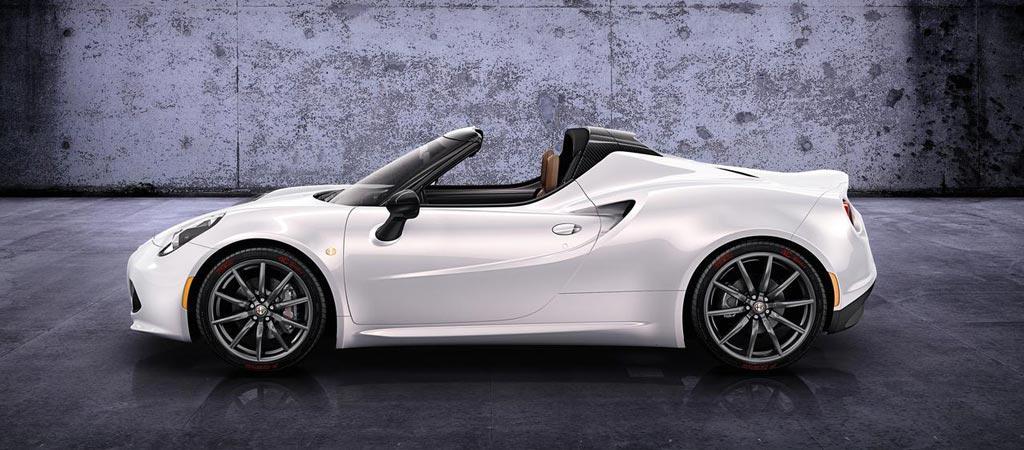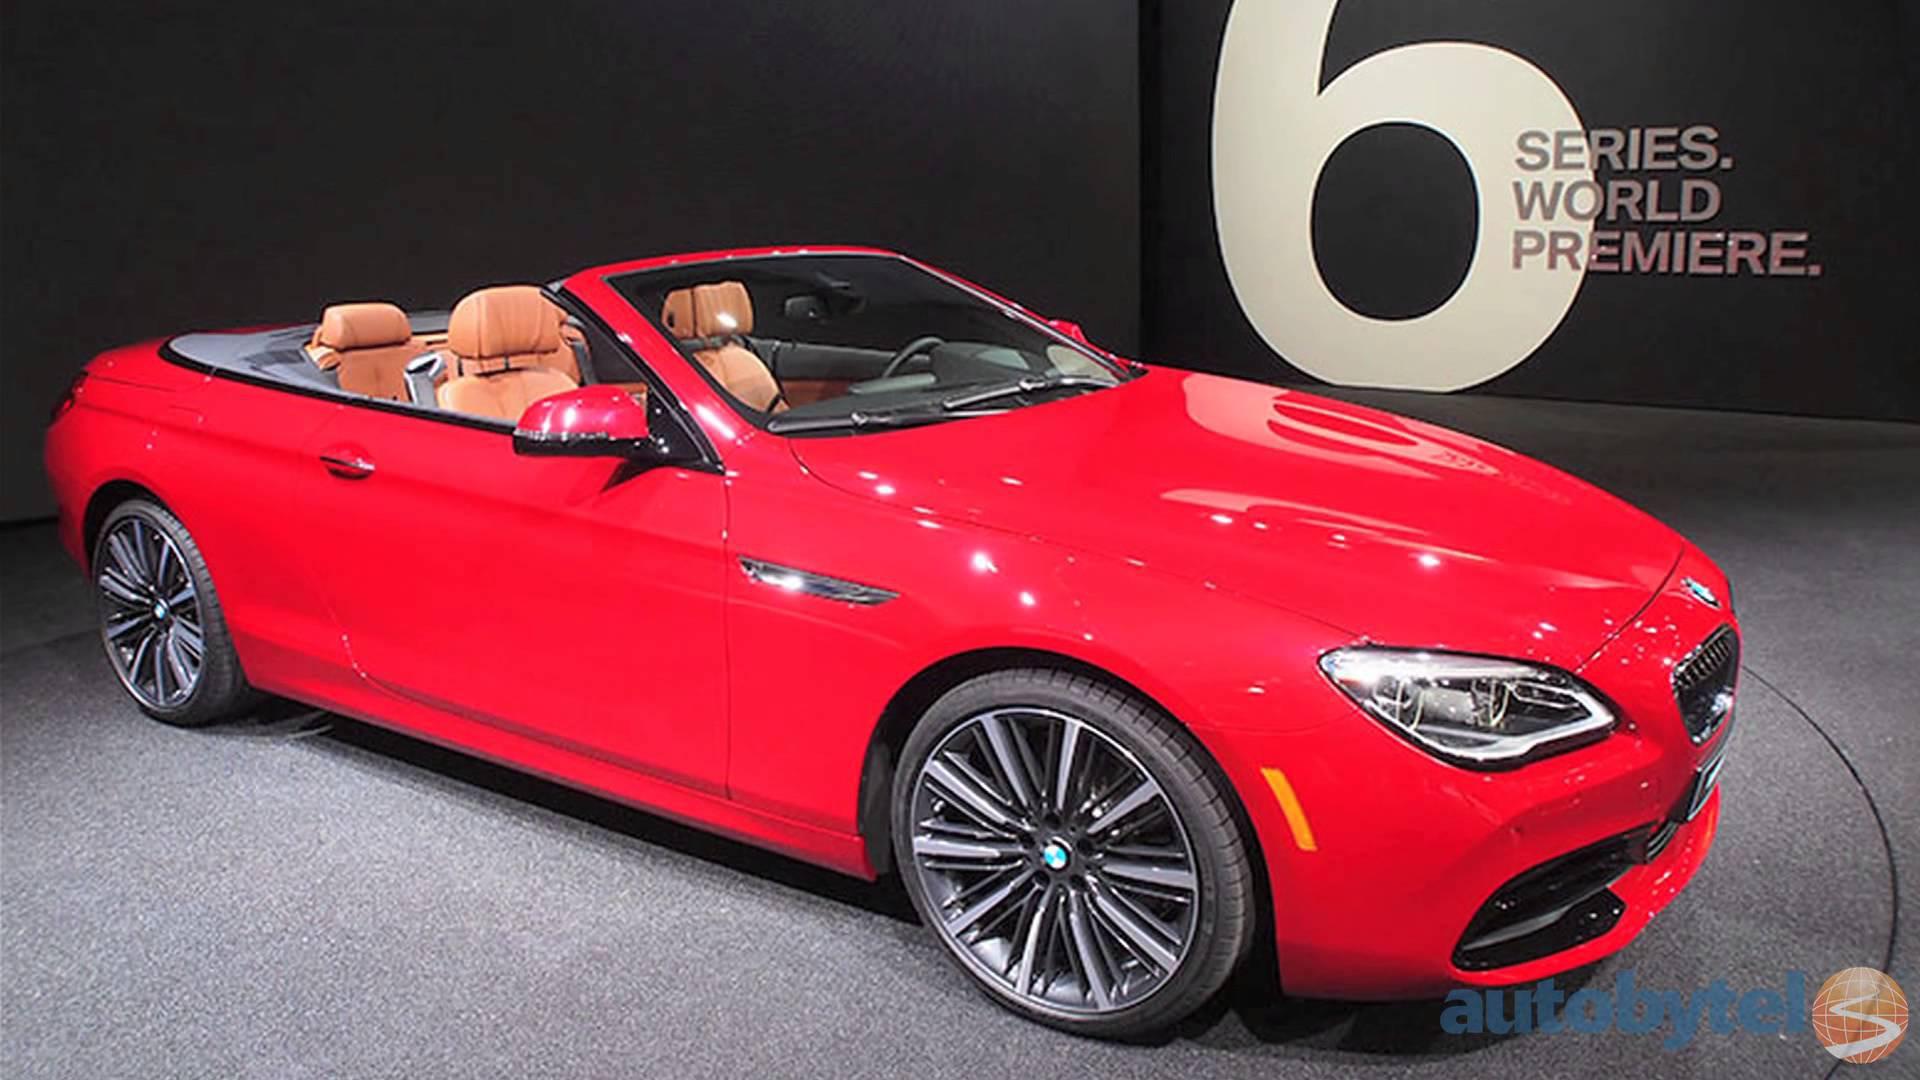The first image is the image on the left, the second image is the image on the right. Examine the images to the left and right. Is the description "Two convertibles with visible headrests, one of them with chrome wheels, are parked and angled in the same direction." accurate? Answer yes or no. No. The first image is the image on the left, the second image is the image on the right. Evaluate the accuracy of this statement regarding the images: "The cars in the left and right images are each turned leftward, and one car is pictured in front of water and peaks of land.". Is it true? Answer yes or no. No. 